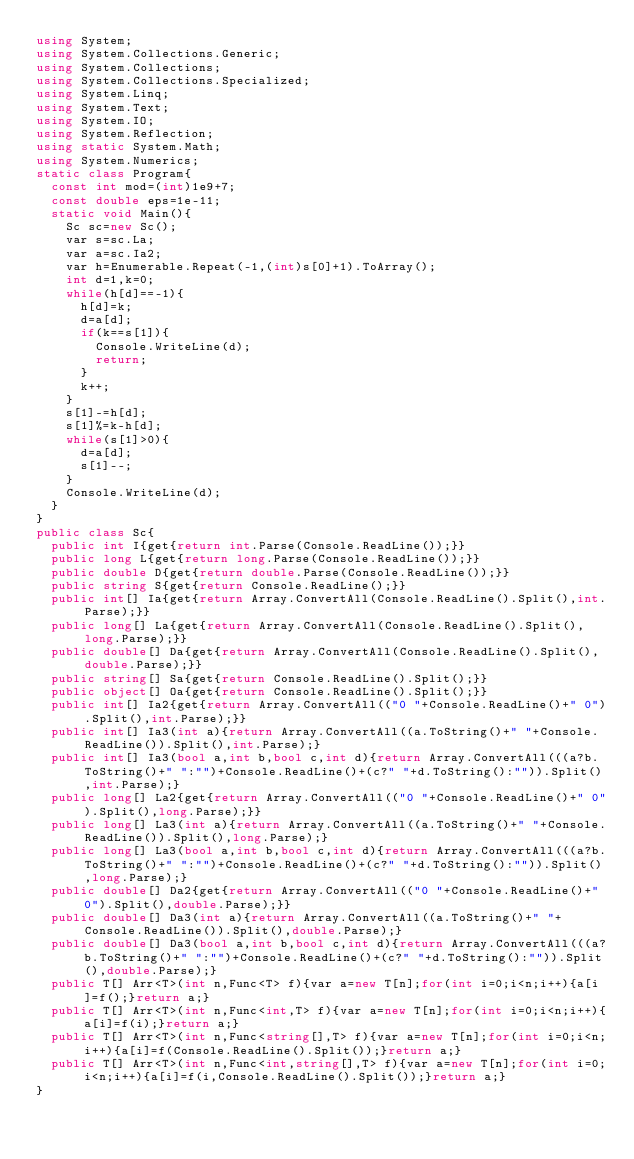Convert code to text. <code><loc_0><loc_0><loc_500><loc_500><_C#_>using System;
using System.Collections.Generic;
using System.Collections;
using System.Collections.Specialized;
using System.Linq;
using System.Text;
using System.IO;
using System.Reflection;
using static System.Math;
using System.Numerics;
static class Program{
	const int mod=(int)1e9+7;
	const double eps=1e-11;
	static void Main(){
		Sc sc=new Sc();
		var s=sc.La;
		var a=sc.Ia2;
		var h=Enumerable.Repeat(-1,(int)s[0]+1).ToArray();
		int d=1,k=0;
		while(h[d]==-1){
			h[d]=k;
			d=a[d];
			if(k==s[1]){
				Console.WriteLine(d);
				return;
			}
			k++;
		}
		s[1]-=h[d];
		s[1]%=k-h[d];
		while(s[1]>0){
			d=a[d];
			s[1]--;
		}
		Console.WriteLine(d);
	}
}
public class Sc{
	public int I{get{return int.Parse(Console.ReadLine());}}
	public long L{get{return long.Parse(Console.ReadLine());}}
	public double D{get{return double.Parse(Console.ReadLine());}}
	public string S{get{return Console.ReadLine();}}
	public int[] Ia{get{return Array.ConvertAll(Console.ReadLine().Split(),int.Parse);}}
	public long[] La{get{return Array.ConvertAll(Console.ReadLine().Split(),long.Parse);}}
	public double[] Da{get{return Array.ConvertAll(Console.ReadLine().Split(),double.Parse);}}
	public string[] Sa{get{return Console.ReadLine().Split();}}
	public object[] Oa{get{return Console.ReadLine().Split();}}
	public int[] Ia2{get{return Array.ConvertAll(("0 "+Console.ReadLine()+" 0").Split(),int.Parse);}}
	public int[] Ia3(int a){return Array.ConvertAll((a.ToString()+" "+Console.ReadLine()).Split(),int.Parse);}
	public int[] Ia3(bool a,int b,bool c,int d){return Array.ConvertAll(((a?b.ToString()+" ":"")+Console.ReadLine()+(c?" "+d.ToString():"")).Split(),int.Parse);}
	public long[] La2{get{return Array.ConvertAll(("0 "+Console.ReadLine()+" 0").Split(),long.Parse);}}
	public long[] La3(int a){return Array.ConvertAll((a.ToString()+" "+Console.ReadLine()).Split(),long.Parse);}
	public long[] La3(bool a,int b,bool c,int d){return Array.ConvertAll(((a?b.ToString()+" ":"")+Console.ReadLine()+(c?" "+d.ToString():"")).Split(),long.Parse);}
	public double[] Da2{get{return Array.ConvertAll(("0 "+Console.ReadLine()+" 0").Split(),double.Parse);}}
	public double[] Da3(int a){return Array.ConvertAll((a.ToString()+" "+Console.ReadLine()).Split(),double.Parse);}
	public double[] Da3(bool a,int b,bool c,int d){return Array.ConvertAll(((a?b.ToString()+" ":"")+Console.ReadLine()+(c?" "+d.ToString():"")).Split(),double.Parse);}
	public T[] Arr<T>(int n,Func<T> f){var a=new T[n];for(int i=0;i<n;i++){a[i]=f();}return a;}
	public T[] Arr<T>(int n,Func<int,T> f){var a=new T[n];for(int i=0;i<n;i++){a[i]=f(i);}return a;}
	public T[] Arr<T>(int n,Func<string[],T> f){var a=new T[n];for(int i=0;i<n;i++){a[i]=f(Console.ReadLine().Split());}return a;}
	public T[] Arr<T>(int n,Func<int,string[],T> f){var a=new T[n];for(int i=0;i<n;i++){a[i]=f(i,Console.ReadLine().Split());}return a;}
}</code> 